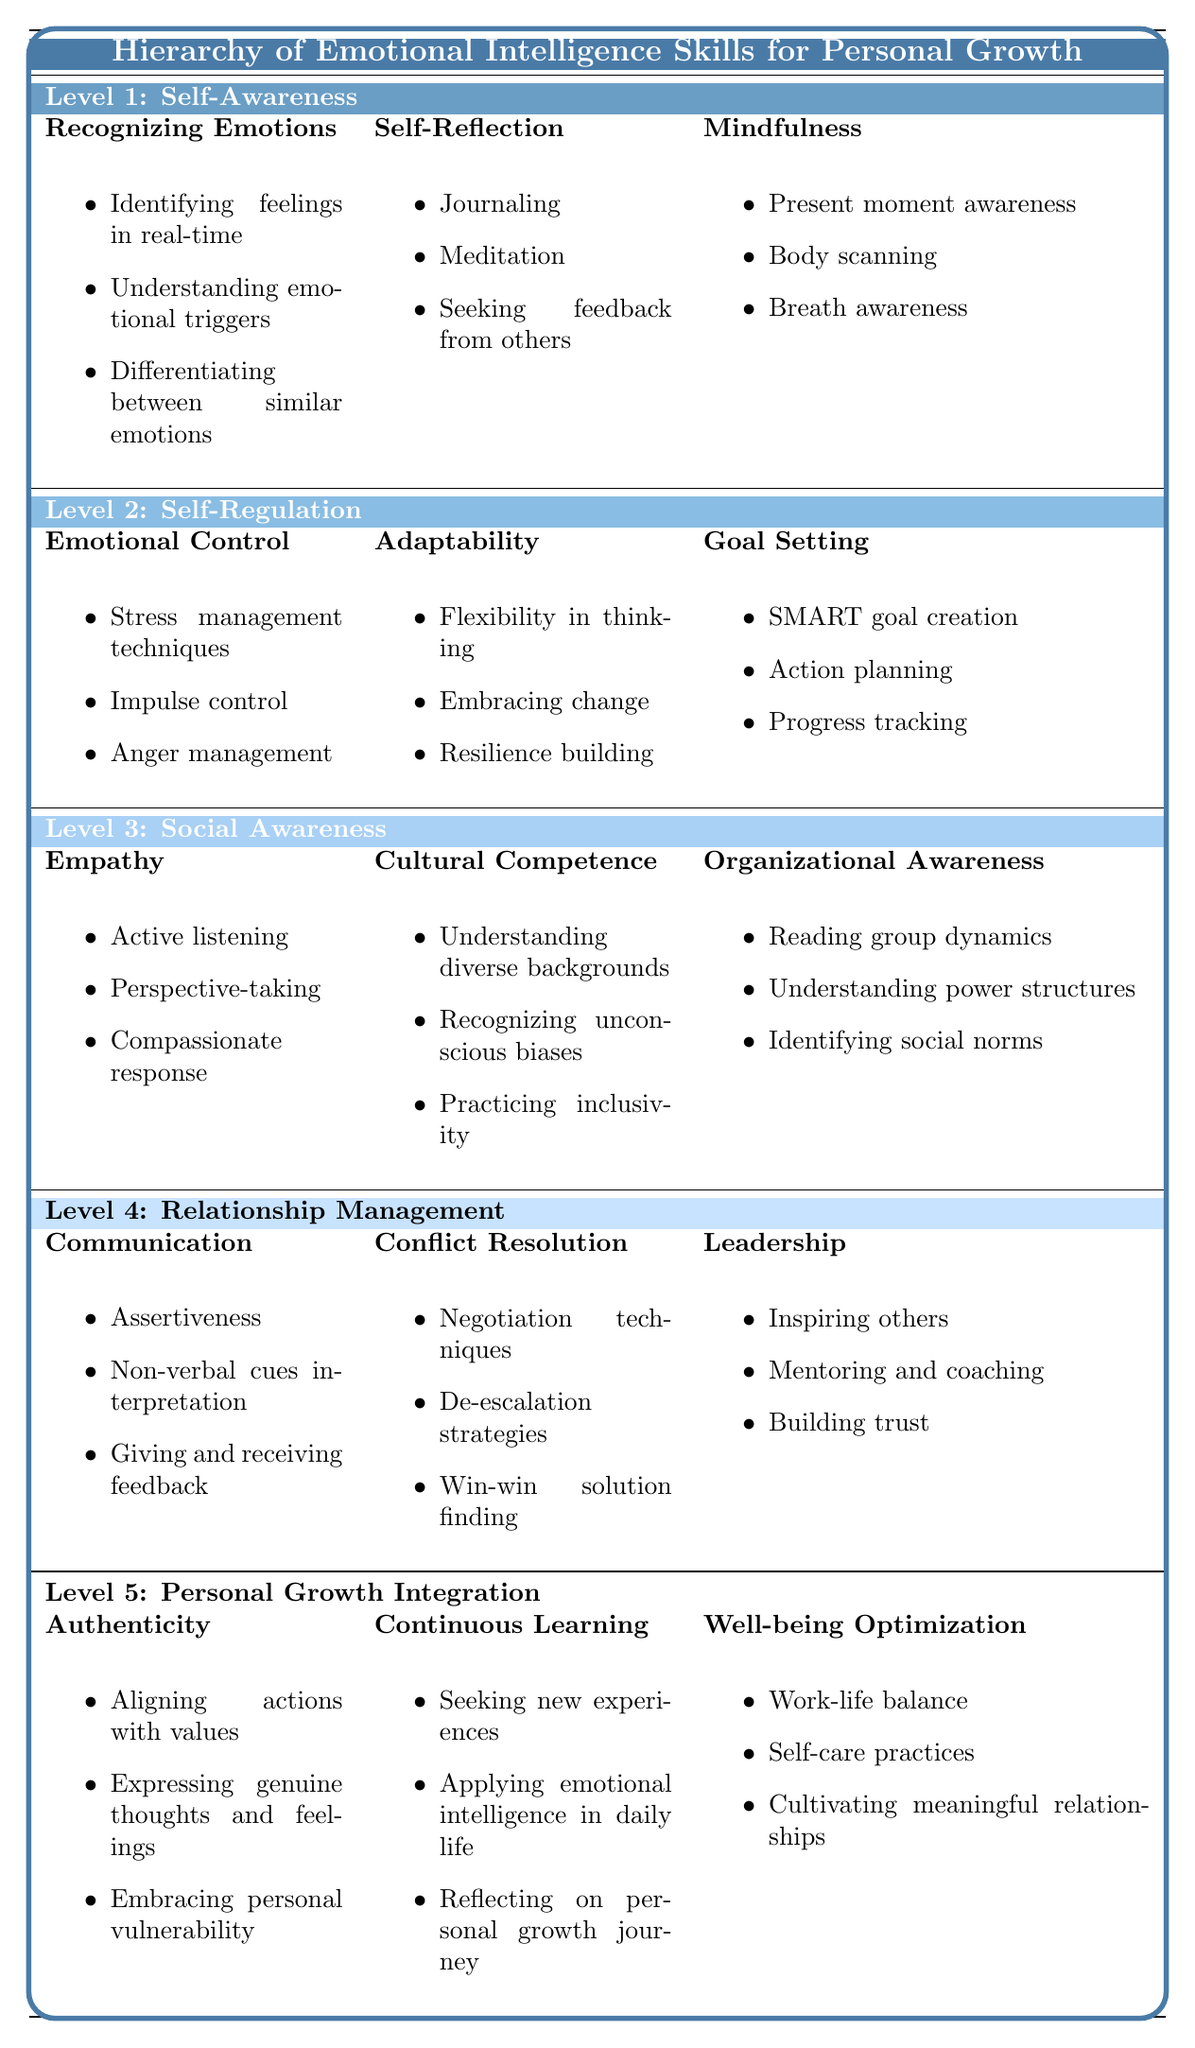What are the three skills listed under Level 1: Self-Awareness? The table indicates that the skills for Level 1: Self-Awareness are Recognizing Emotions, Self-Reflection, and Mindfulness.
Answer: Recognizing Emotions, Self-Reflection, Mindfulness How many components are associated with the skill "Adaptability"? The skill "Adaptability" has three components listed: Flexibility in thinking, Embracing change, and Resilience building.
Answer: 3 Is "Cultural Competence" part of Level 3: Social Awareness? According to the table, Cultural Competence is indeed listed under Level 3: Social Awareness.
Answer: Yes Which skills are focused on relationship management? The table specifies that the skills for Relationship Management include Communication, Conflict Resolution, and Leadership.
Answer: Communication, Conflict Resolution, Leadership What components of "Authenticity" are related to personal values? The components of "Authenticity" related to personal values include Aligning actions with values, Expressing genuine thoughts and feelings, and Embracing personal vulnerability.
Answer: Aligning actions with values, Expressing genuine thoughts and feelings, Embracing personal vulnerability Which level contains the skill "Emotional Control"? The skill "Emotional Control" is listed under Level 2: Self-Regulation in the table.
Answer: Level 2: Self-Regulation What is the total number of skills presented in Level 5: Personal Growth Integration? There are three skills listed under Level 5: Personal Growth Integration: Authenticity, Continuous Learning, and Well-being Optimization.
Answer: 3 Which component is not found under "Self-Reflection"? The component “Practicing mindfulness” is not found under Self-Reflection, as its components are Journaling, Meditation, and Seeking feedback from others.
Answer: Practicing mindfulness Can you summarize the components associated with the skill "Goal Setting"? The components associated with "Goal Setting" are SMART goal creation, Action planning, and Progress tracking as listed under Level 2: Self-Regulation.
Answer: SMART goal creation, Action planning, Progress tracking Are there any components related to "Well-being Optimization" that mention self-care? Yes, one of the components associated with "Well-being Optimization" is Self-care practices, indicating it mentions self-care directly.
Answer: Yes Identify two components of "Empathy." Two components of "Empathy" are Active listening and Perspective-taking, both of which are listed under the skill.
Answer: Active listening, Perspective-taking What is the skill that involves "Inspiring others"? The skill that involves "Inspiring others" is Leadership, which is found under Level 4: Relationship Management.
Answer: Leadership How does the number of skills increase as you move from Level 1 to Level 5? Level 1 has 3 skills, Level 2 has 3 skills, Level 3 has 3 skills, Level 4 has 3 skills, and Level 5 has 3 skills; hence, the count remains the same throughout.
Answer: The number remains constant at 3 across all levels 